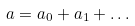Convert formula to latex. <formula><loc_0><loc_0><loc_500><loc_500>a = a _ { 0 } + a _ { 1 } + \dots</formula> 